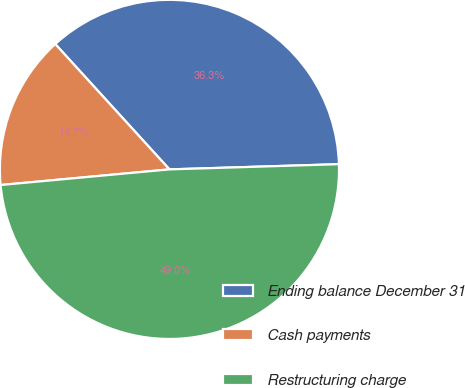Convert chart to OTSL. <chart><loc_0><loc_0><loc_500><loc_500><pie_chart><fcel>Ending balance December 31<fcel>Cash payments<fcel>Restructuring charge<nl><fcel>36.27%<fcel>14.71%<fcel>49.02%<nl></chart> 